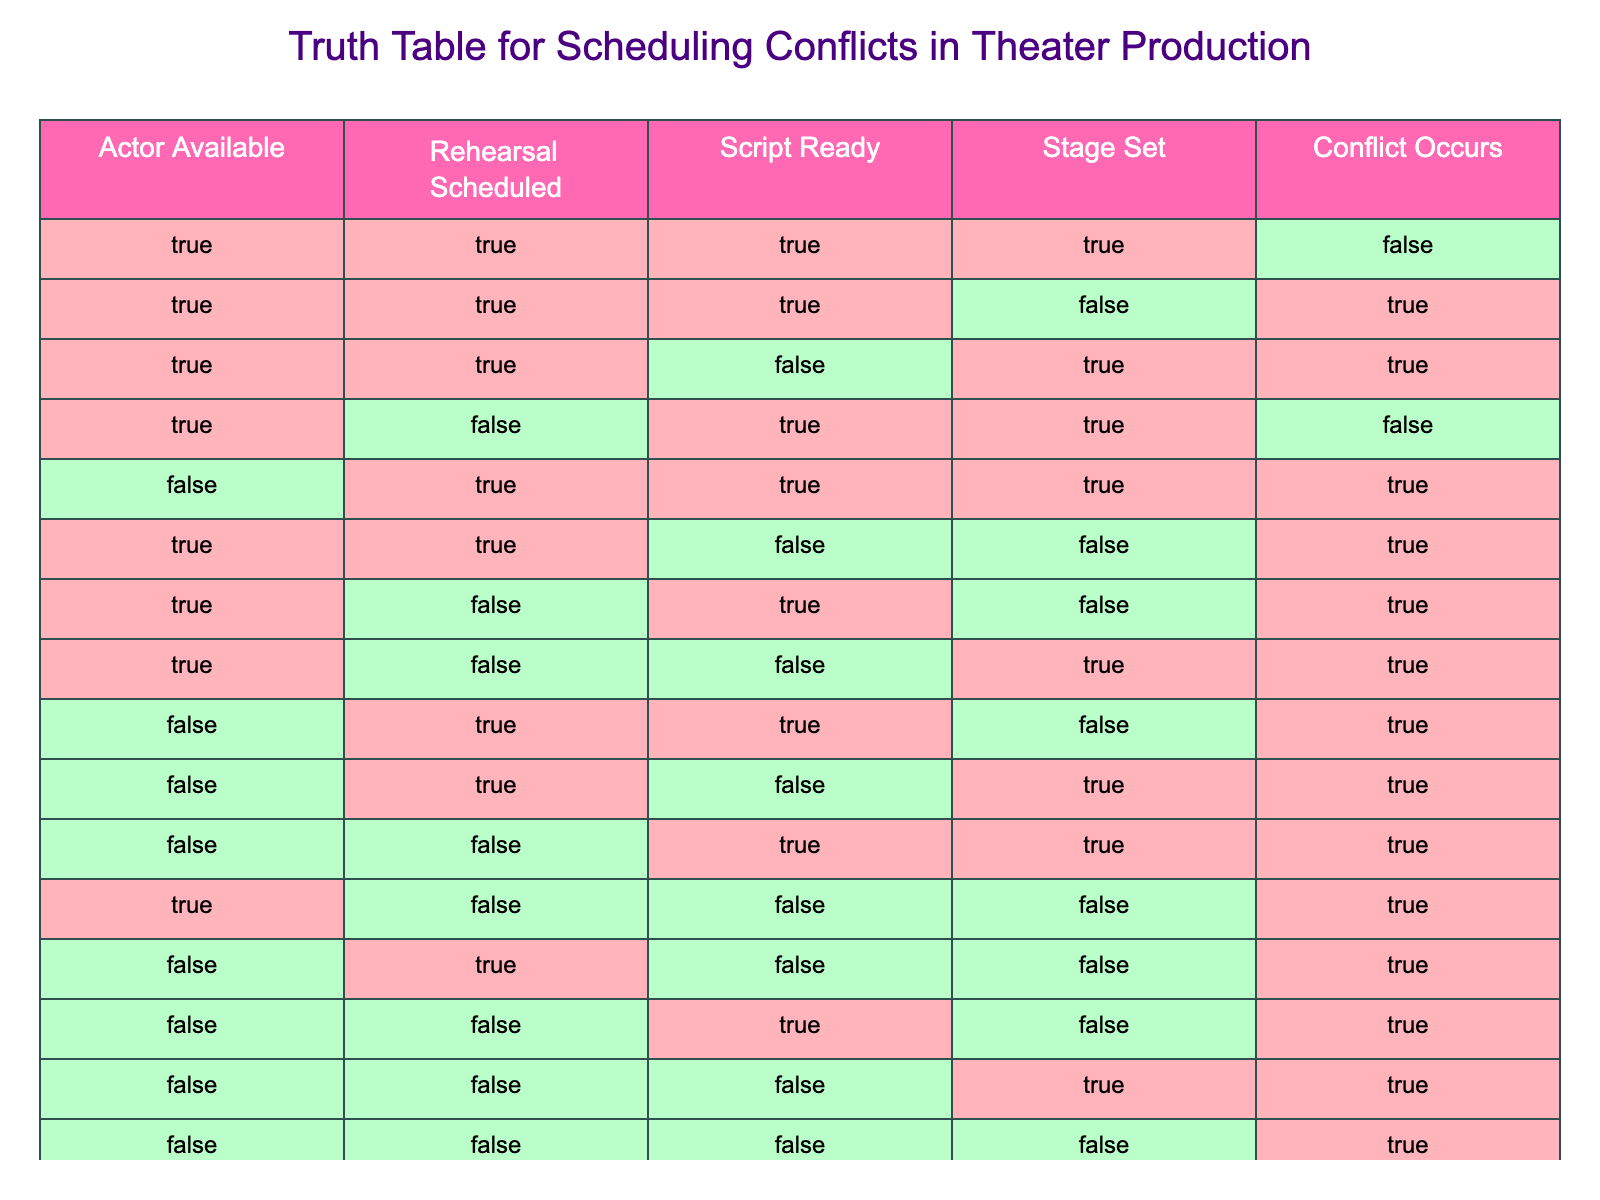What is the condition under which no conflict occurs? Referring to the table, a conflict does not occur when all conditions are true: Actor Available, Rehearsal Scheduled, Script Ready, and Stage Set. This is found in the first row of the table.
Answer: All true conditions How many times does an actor being unavailable lead to a conflict? By reviewing the rows where "Actor Available" is false, we see there are 6 instances (rows 5, 9, 10, 12, 14, and 15) where a conflict occurs.
Answer: 6 times What is the total number of conflicts when the stage is set? To find this, count the rows where "Stage Set" is true, which are rows 1, 3, 4, 5, 11, and 15. Out of these, only rows 1 and 4 do not have a conflict, so there are 4 conflicts when the stage is set.
Answer: 4 Is there ever a situation where the rehearsal is scheduled without a conflict? Checking the rows with "Rehearsal Scheduled" as true (rows 1, 2, 3, 5, 9, 10, 11, 12, and 14), only row 1 shows no conflict. Thus, the answer is yes, there is one such situation.
Answer: Yes What are the conditions leading to conflicts when the script is not ready? By filtering the rows where "Script Ready" is false (rows 2, 6, 7, 11, 12, 14, and 15), we find that conflicts occur in rows 2, 6, 7, 11, 12, 14, and 15 under different conditions. This implies that the combination of other factors contributes to conflicts.
Answer: Multiple conditions contribute What is the percentage of total rows that lead to a conflict? There are 15 rows in total, and 10 of them lead to a conflict. To find the percentage, divide the number of conflict rows by total rows and multiply by 100: (10/15) * 100 = 66.67%.
Answer: Approximately 66.67% In how many scenarios is it possible for the rehearsal to be scheduled if the actor is not available? From the table, looking at rows where "Actor Available" is false (rows 5, 9, 10, 12, 14, and 15), the rehearsal is scheduled in 4 instances (rows 5, 9, 10, and 12).
Answer: 4 scenarios Can a rehearsal be scheduled with the script ready without a conflict? Yes, by examining the table, row 1 has both "Rehearsal Scheduled" and "Script Ready" marked true without a conflict, confirming that such a scenario exists.
Answer: Yes What is the overall relationship between the availability of the actor and conflicts? Analyzing the table, it appears that whenever the actor is not available, conflicts arise in 6 instances out of 6, indicating a strong direct relationship that an unavailable actor means a conflict.
Answer: Strong relationship 